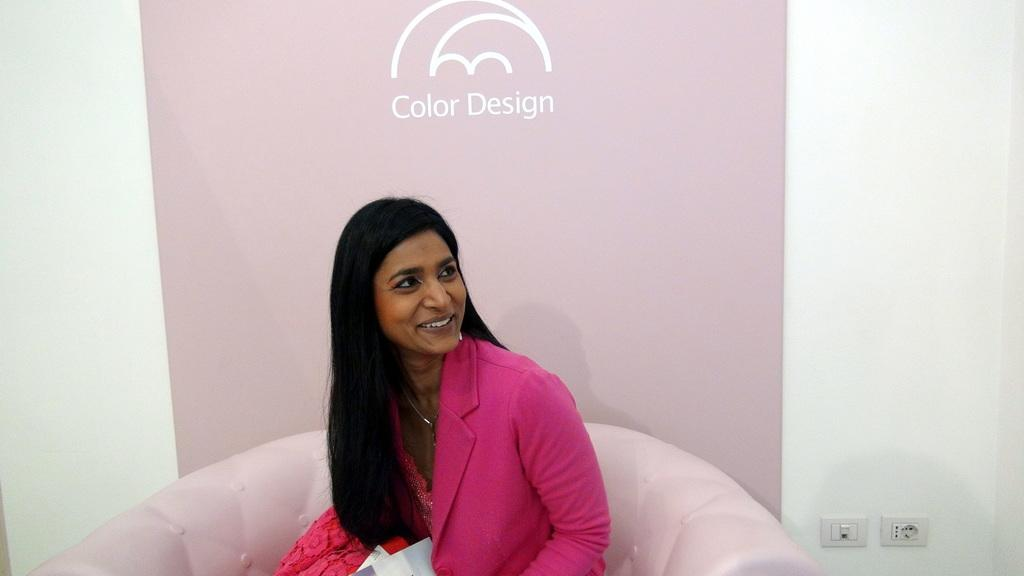What is the color of the wall in the image? There is a white color wall in the image. What else can be seen hanging on the wall? There is a banner in the image. What is the woman in the image wearing? The woman is wearing a pink color dress. What is the woman doing in the image? The woman is sitting on a sofa. Where are the switch boards located in the image? The switch boards are on the right side of the image. What action is the beggar performing in the image? There is no beggar present in the image. What is the color of the top worn by the woman in the image? The woman is not wearing a top; she is wearing a pink color dress. 